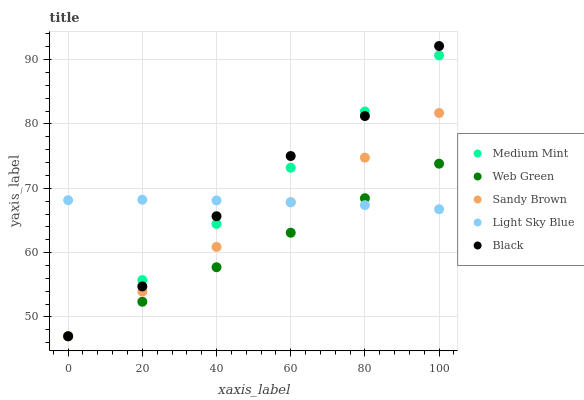Does Web Green have the minimum area under the curve?
Answer yes or no. Yes. Does Black have the maximum area under the curve?
Answer yes or no. Yes. Does Light Sky Blue have the minimum area under the curve?
Answer yes or no. No. Does Light Sky Blue have the maximum area under the curve?
Answer yes or no. No. Is Web Green the smoothest?
Answer yes or no. Yes. Is Black the roughest?
Answer yes or no. Yes. Is Light Sky Blue the smoothest?
Answer yes or no. No. Is Light Sky Blue the roughest?
Answer yes or no. No. Does Medium Mint have the lowest value?
Answer yes or no. Yes. Does Light Sky Blue have the lowest value?
Answer yes or no. No. Does Black have the highest value?
Answer yes or no. Yes. Does Light Sky Blue have the highest value?
Answer yes or no. No. Does Web Green intersect Medium Mint?
Answer yes or no. Yes. Is Web Green less than Medium Mint?
Answer yes or no. No. Is Web Green greater than Medium Mint?
Answer yes or no. No. 